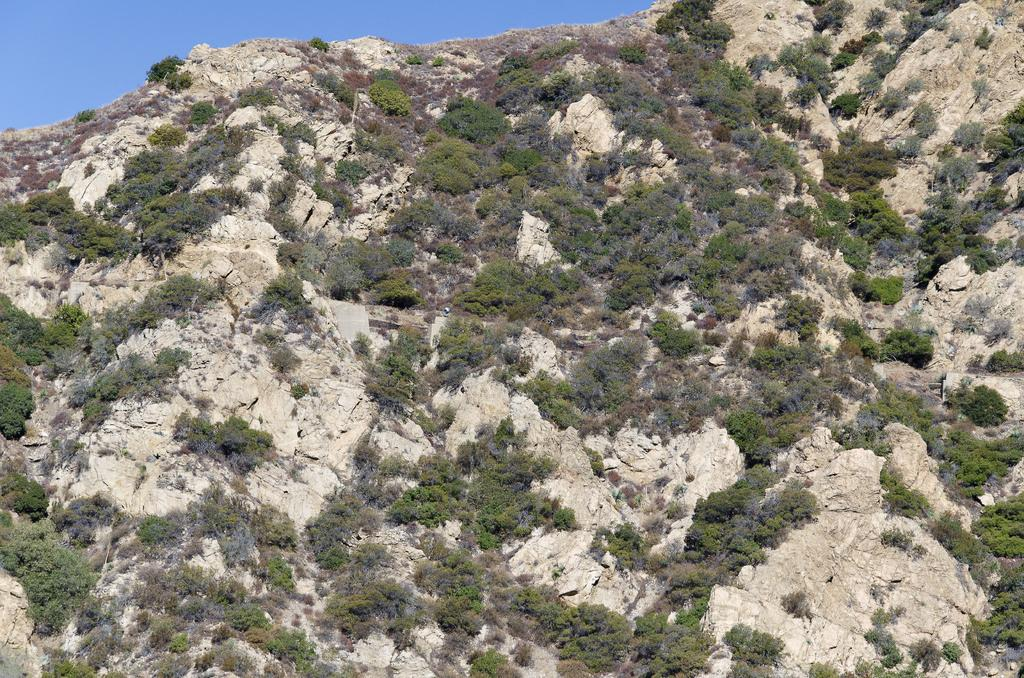Where was the image taken? The image is clicked outside the city. What type of natural elements can be seen in the image? There are plants and a rock visible in the image. What is visible in the background of the image? The sky is visible in the background of the image. What song is being sung by the plants in the image? There are no plants singing in the image; plants do not have the ability to sing. How many hands are visible in the image? There are no hands visible in the image. 